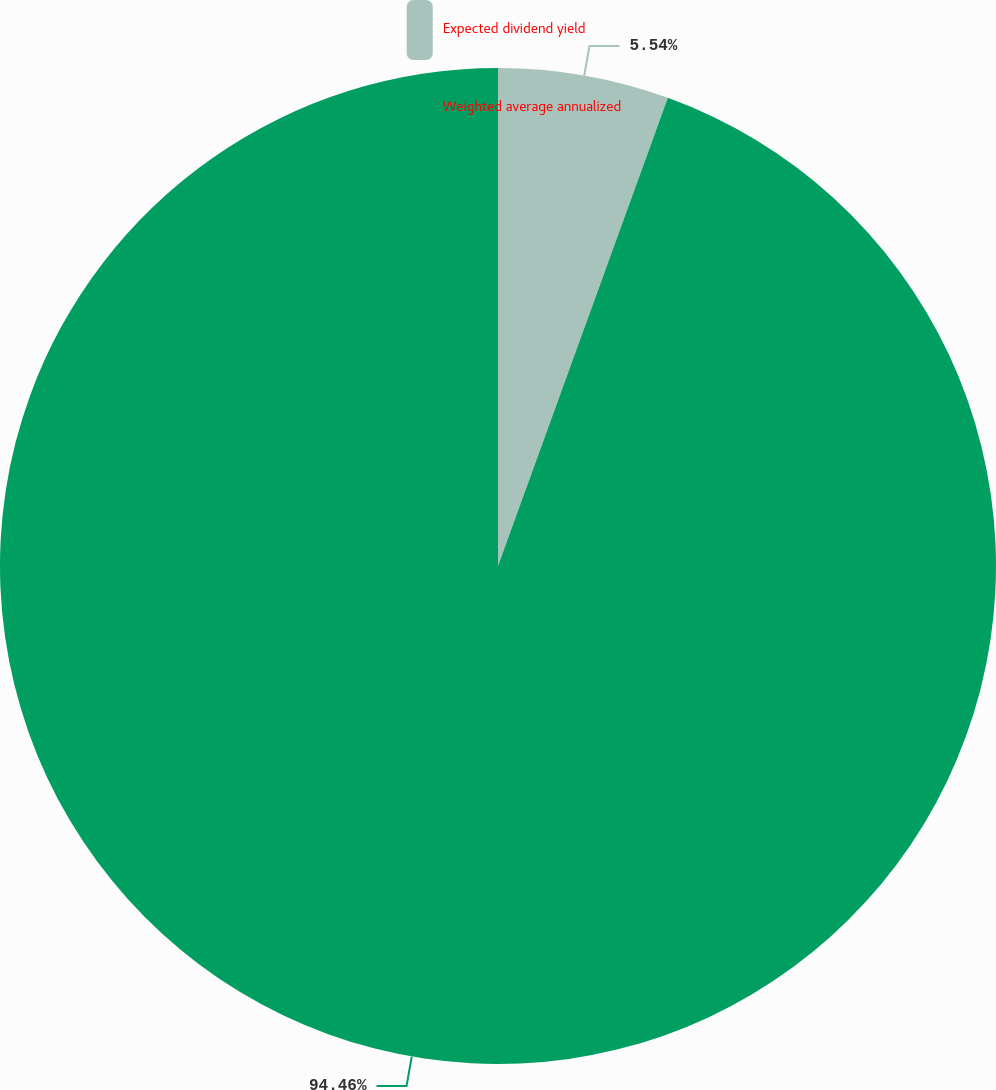Convert chart to OTSL. <chart><loc_0><loc_0><loc_500><loc_500><pie_chart><fcel>Expected dividend yield<fcel>Weighted average annualized<nl><fcel>5.54%<fcel>94.46%<nl></chart> 